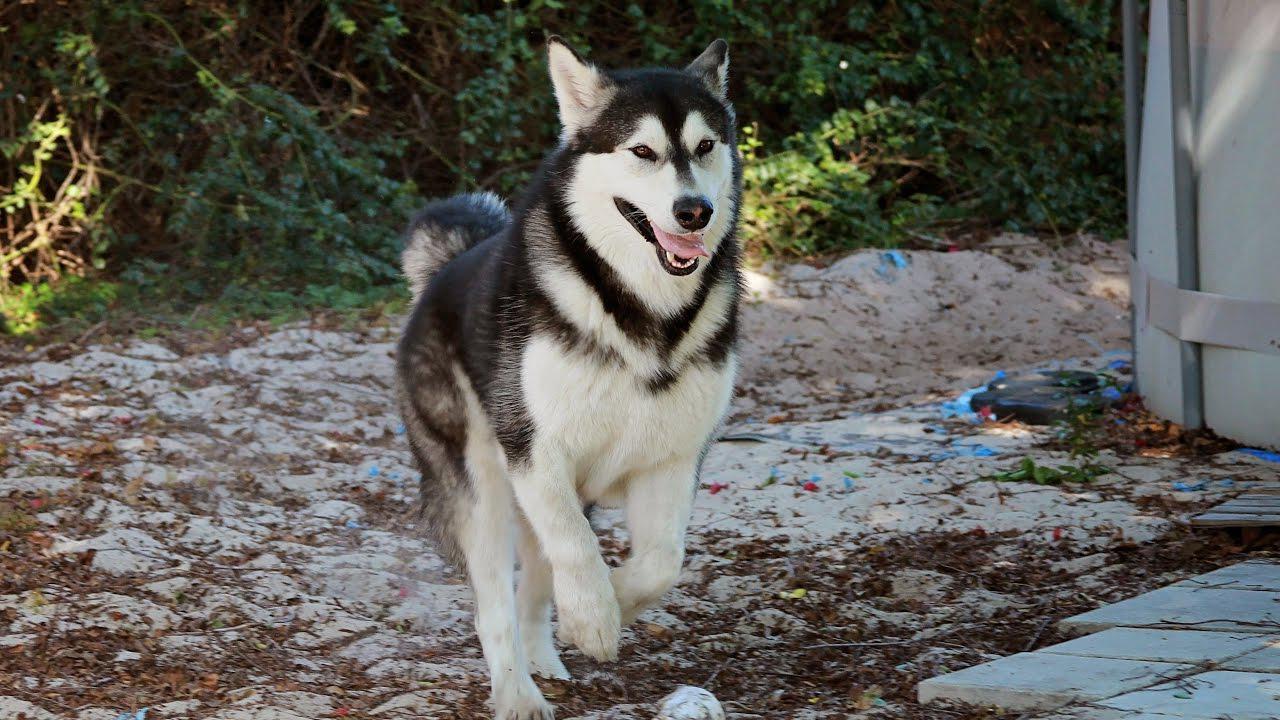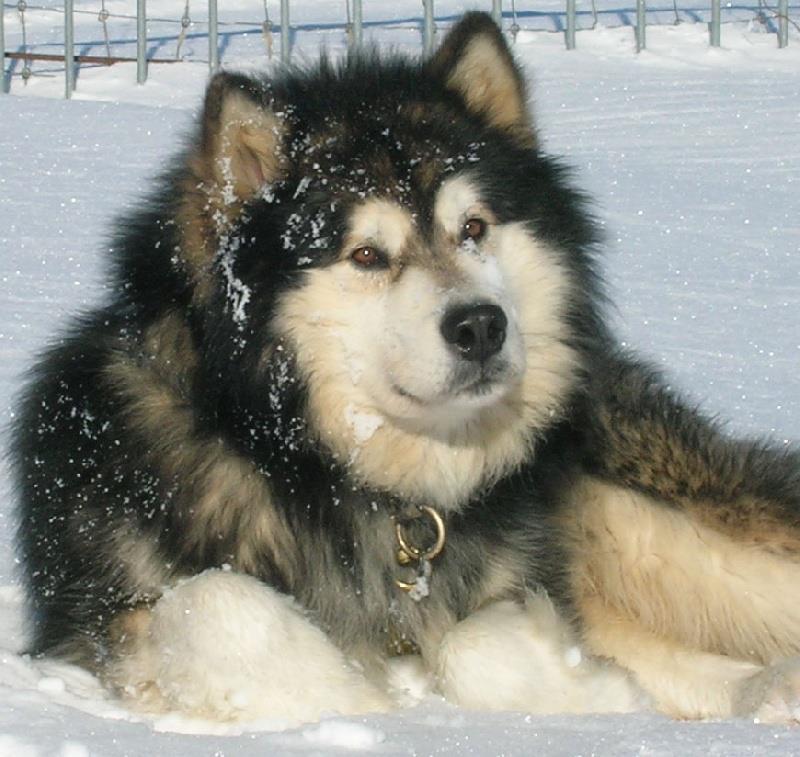The first image is the image on the left, the second image is the image on the right. For the images displayed, is the sentence "The dogs in both pictures are looking to the right." factually correct? Answer yes or no. Yes. The first image is the image on the left, the second image is the image on the right. Evaluate the accuracy of this statement regarding the images: "The left image features a dog with an open mouth standing in profile in front of someone standing wearing pants.". Is it true? Answer yes or no. No. 